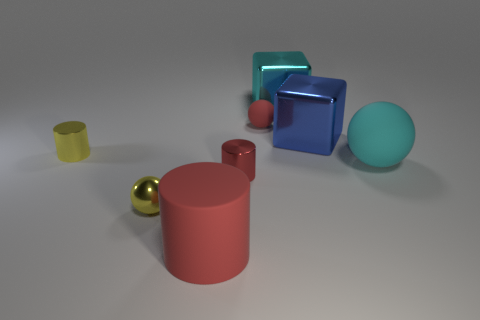There is a sphere that is the same size as the red matte cylinder; what color is it?
Ensure brevity in your answer.  Cyan. The yellow object behind the tiny sphere that is in front of the red object behind the blue metallic object is what shape?
Ensure brevity in your answer.  Cylinder. What is the shape of the small matte object that is the same color as the rubber cylinder?
Your answer should be very brief. Sphere. How many objects are either large shiny objects or blue objects that are behind the yellow shiny cylinder?
Give a very brief answer. 2. There is a ball that is left of the matte cylinder; is it the same size as the big blue thing?
Provide a short and direct response. No. There is a red cylinder that is on the right side of the big cylinder; what material is it?
Offer a very short reply. Metal. Are there the same number of cyan matte spheres that are behind the cyan shiny cube and blue shiny objects to the left of the big blue cube?
Your answer should be very brief. Yes. There is another tiny shiny object that is the same shape as the small red metallic thing; what color is it?
Give a very brief answer. Yellow. Are there any other things that have the same color as the big sphere?
Ensure brevity in your answer.  Yes. How many matte objects are either purple cubes or large blue things?
Give a very brief answer. 0. 